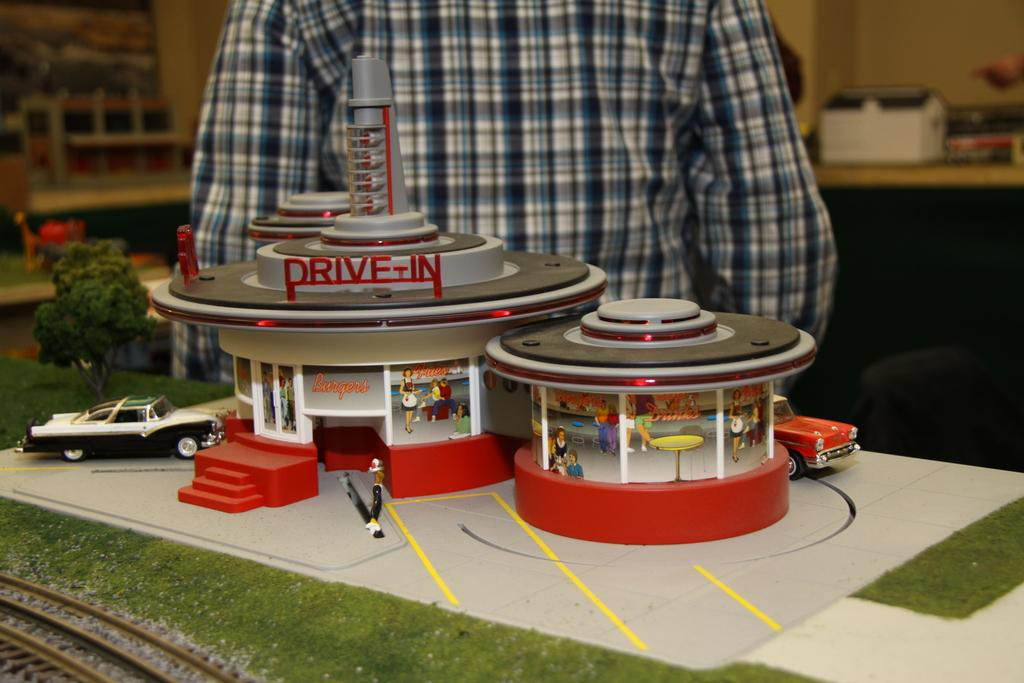What is located at the bottom of the image? There is a table at the bottom of the image. What can be seen on the table? There are toys on the table. Is there anyone near the table? Yes, a person is standing behind the table. What type of volcano can be seen erupting in the background of the image? There is no volcano present in the image; it only features a table, toys, and a person standing behind the table. 